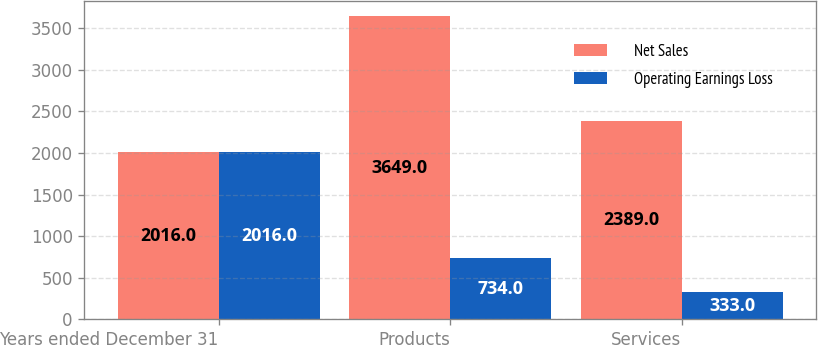Convert chart. <chart><loc_0><loc_0><loc_500><loc_500><stacked_bar_chart><ecel><fcel>Years ended December 31<fcel>Products<fcel>Services<nl><fcel>Net Sales<fcel>2016<fcel>3649<fcel>2389<nl><fcel>Operating Earnings Loss<fcel>2016<fcel>734<fcel>333<nl></chart> 